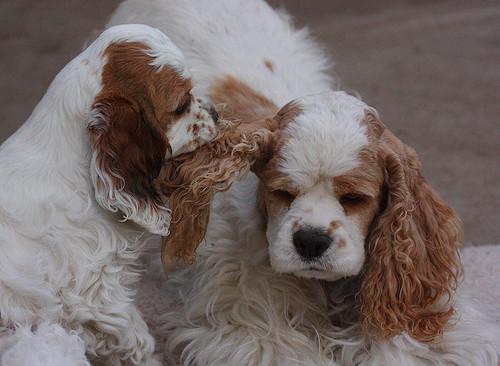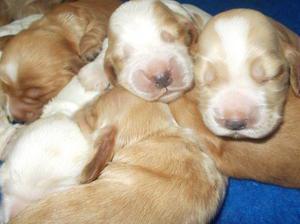The first image is the image on the left, the second image is the image on the right. Assess this claim about the two images: "There are two dogs in the lefthand image.". Correct or not? Answer yes or no. Yes. 